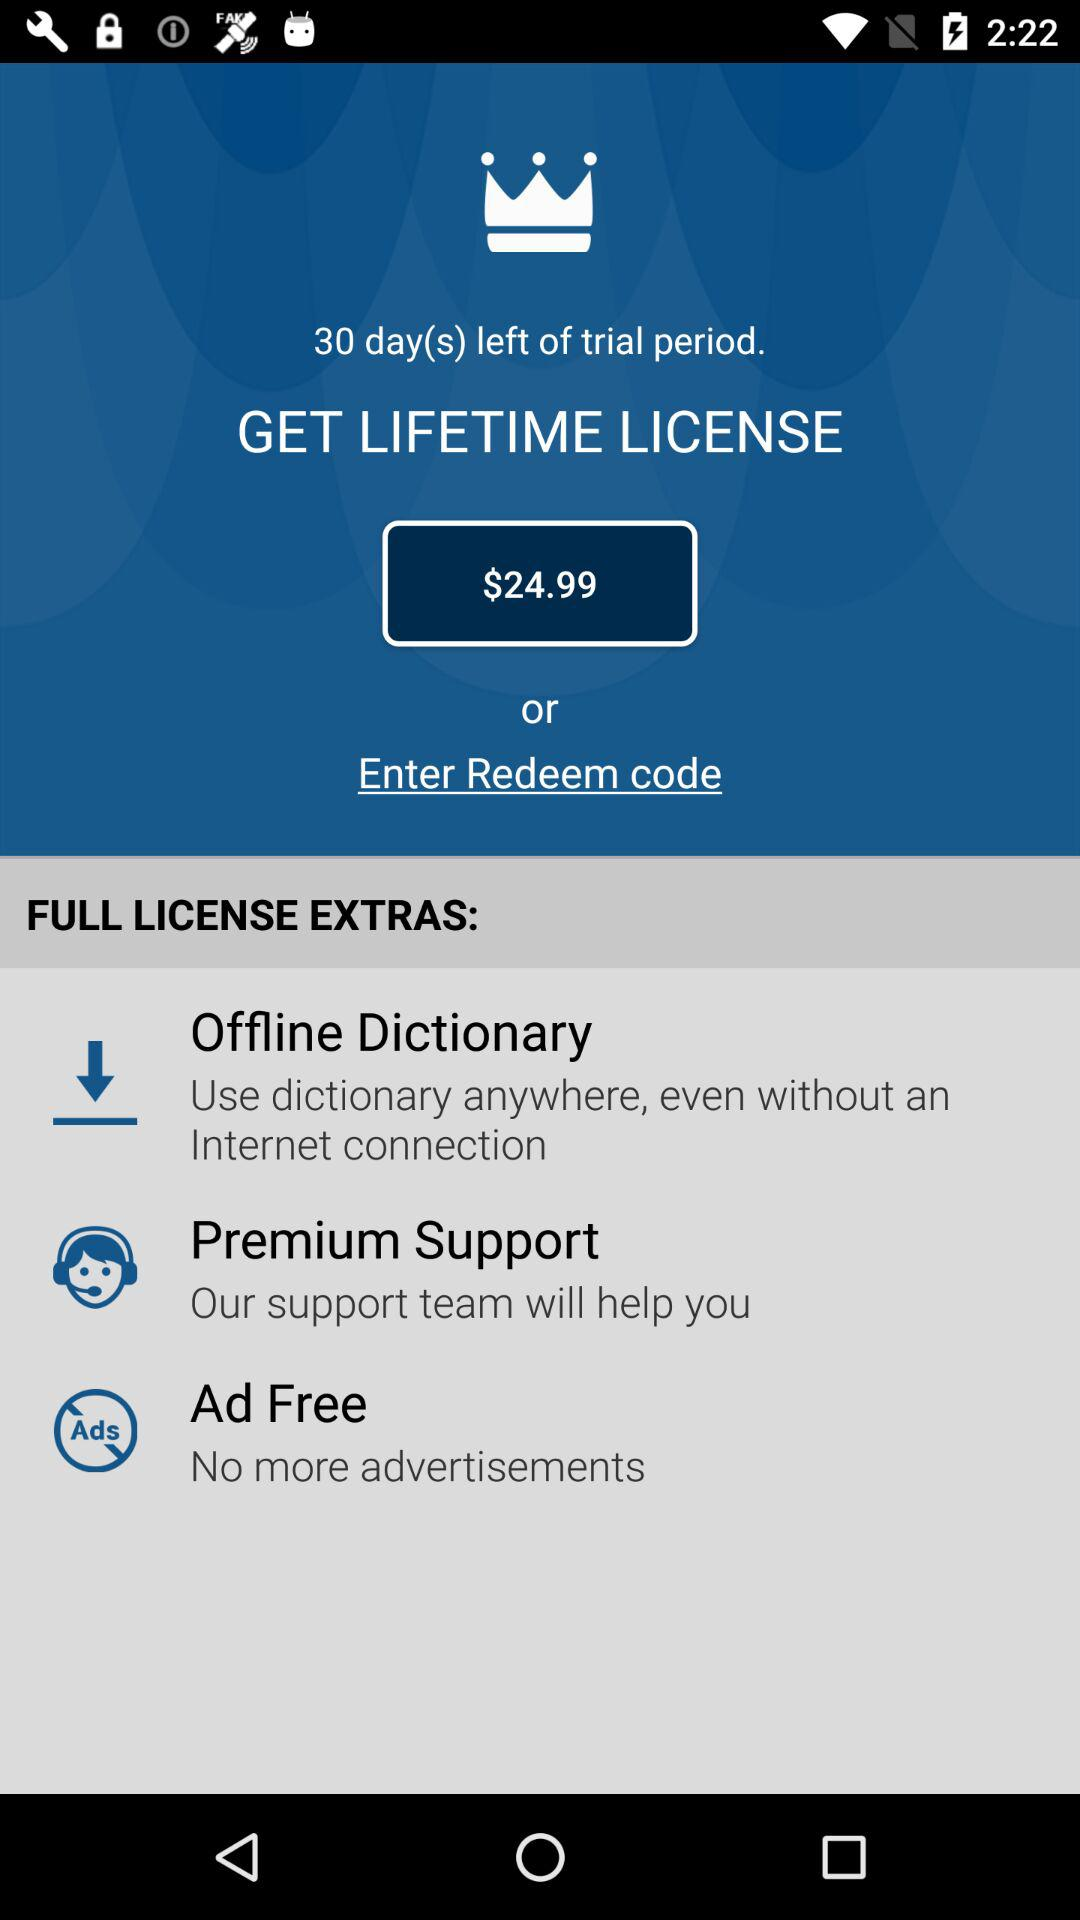What is the price of the lifetime license? The price of the lifetime license is $24.99. 